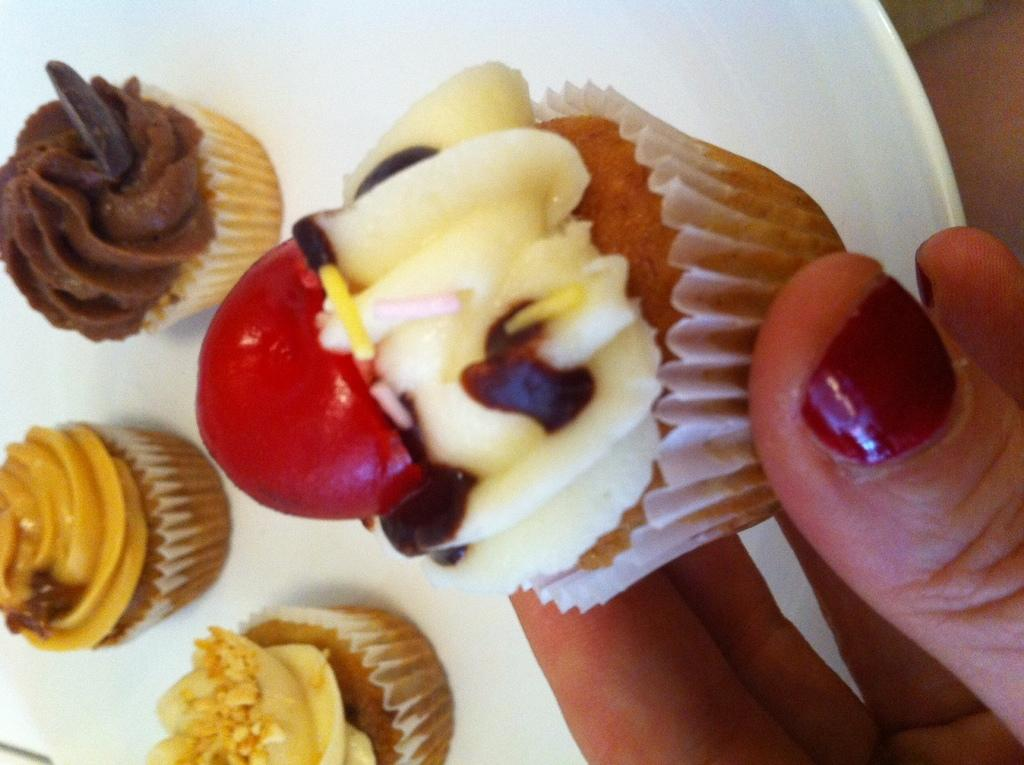What is on the plate that is visible in the image? There are cupcakes on the plate in the image. What is the person in the image doing with the cupcakes? There is a hand holding a cupcake on the right side of the image, suggesting that the person is about to eat or serve the cupcake. Can you describe the plate in the image? The plate is visible in the image, but no specific details about its appearance are provided. What type of cat can be seen sitting on the door in the image? There is no cat or door present in the image; it only features a plate with cupcakes and a hand holding a cupcake. Is there a hydrant visible in the image? There is no hydrant present in the image. 